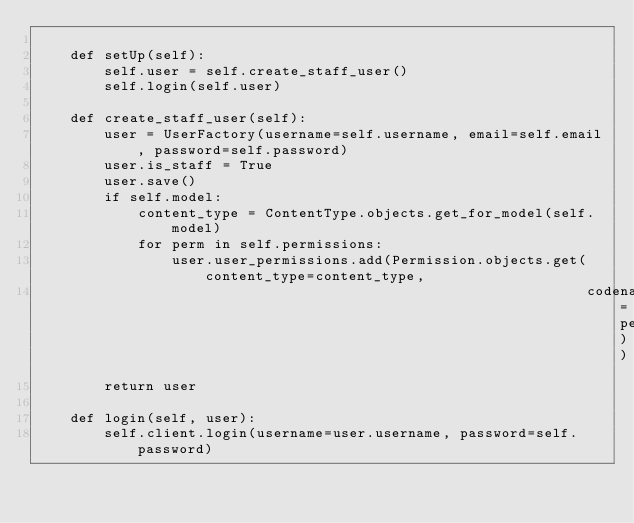Convert code to text. <code><loc_0><loc_0><loc_500><loc_500><_Python_>
    def setUp(self):
        self.user = self.create_staff_user()
        self.login(self.user)

    def create_staff_user(self):
        user = UserFactory(username=self.username, email=self.email, password=self.password)
        user.is_staff = True
        user.save()
        if self.model:
            content_type = ContentType.objects.get_for_model(self.model)
            for perm in self.permissions:
                user.user_permissions.add(Permission.objects.get(content_type=content_type,
                                                                 codename=perm))
        return user

    def login(self, user):
        self.client.login(username=user.username, password=self.password)
</code> 